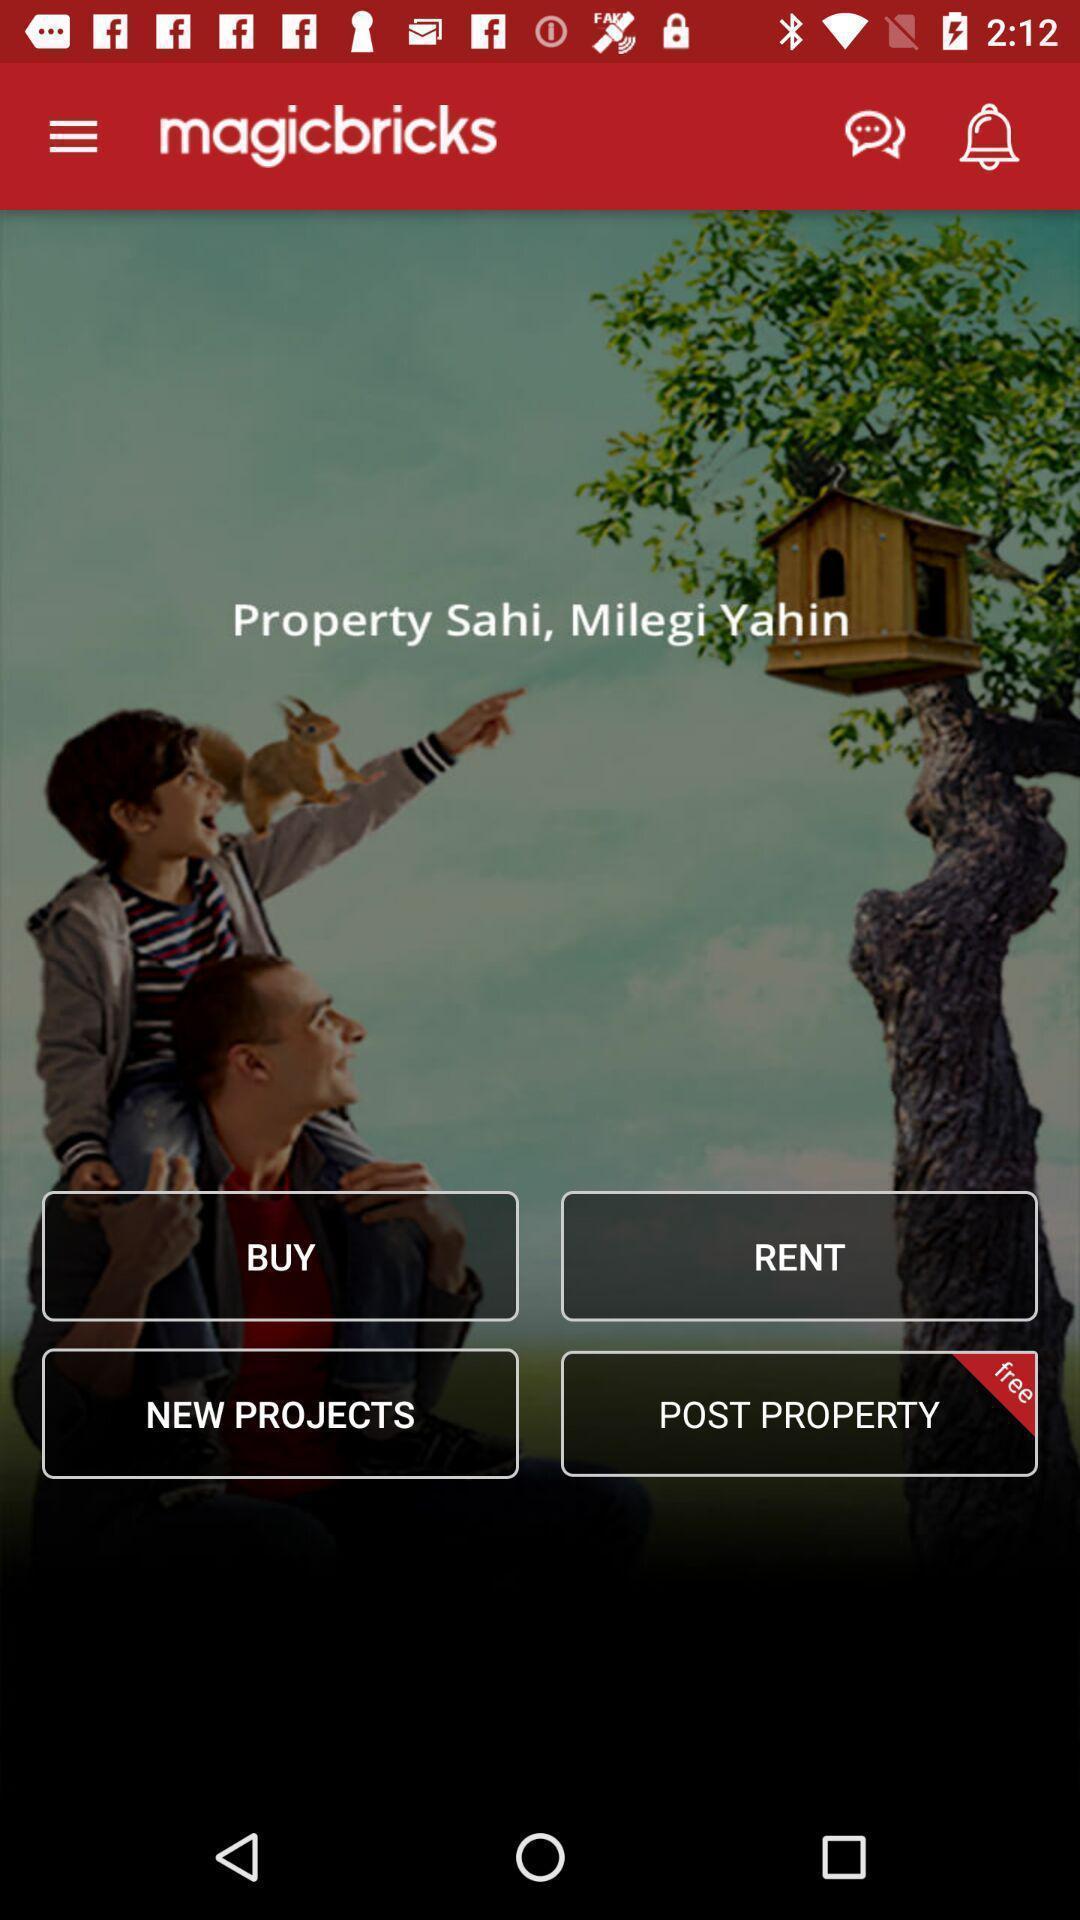Give me a narrative description of this picture. Shopping page. 